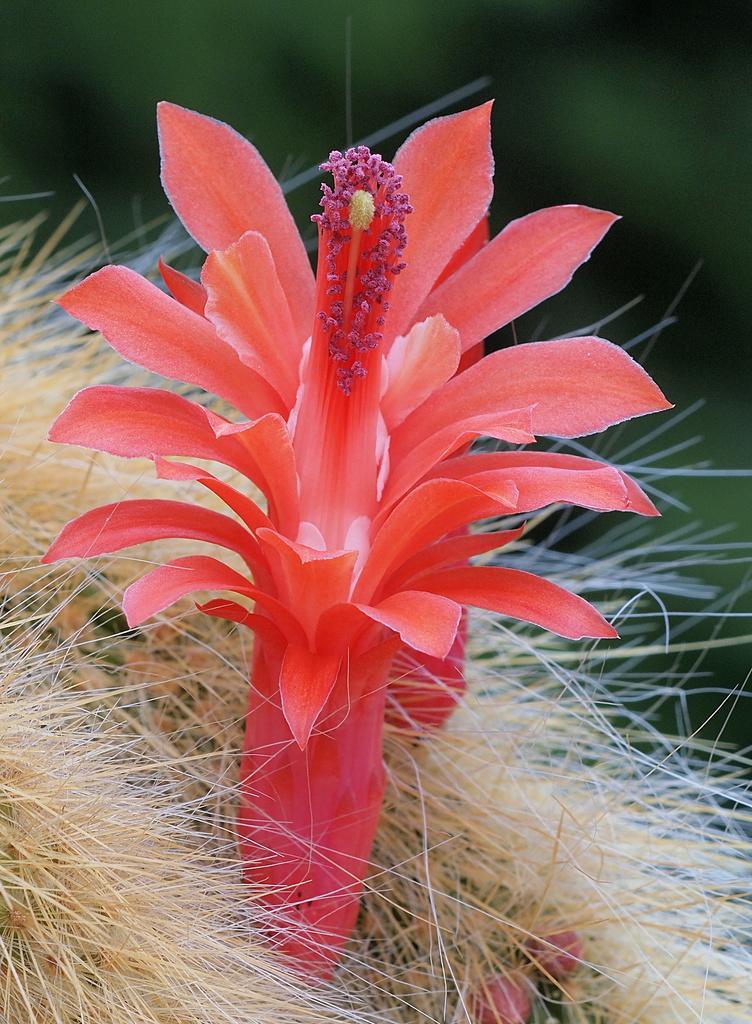Could you give a brief overview of what you see in this image? As we can see in the image in the front there is a flower. The background is blurred. 